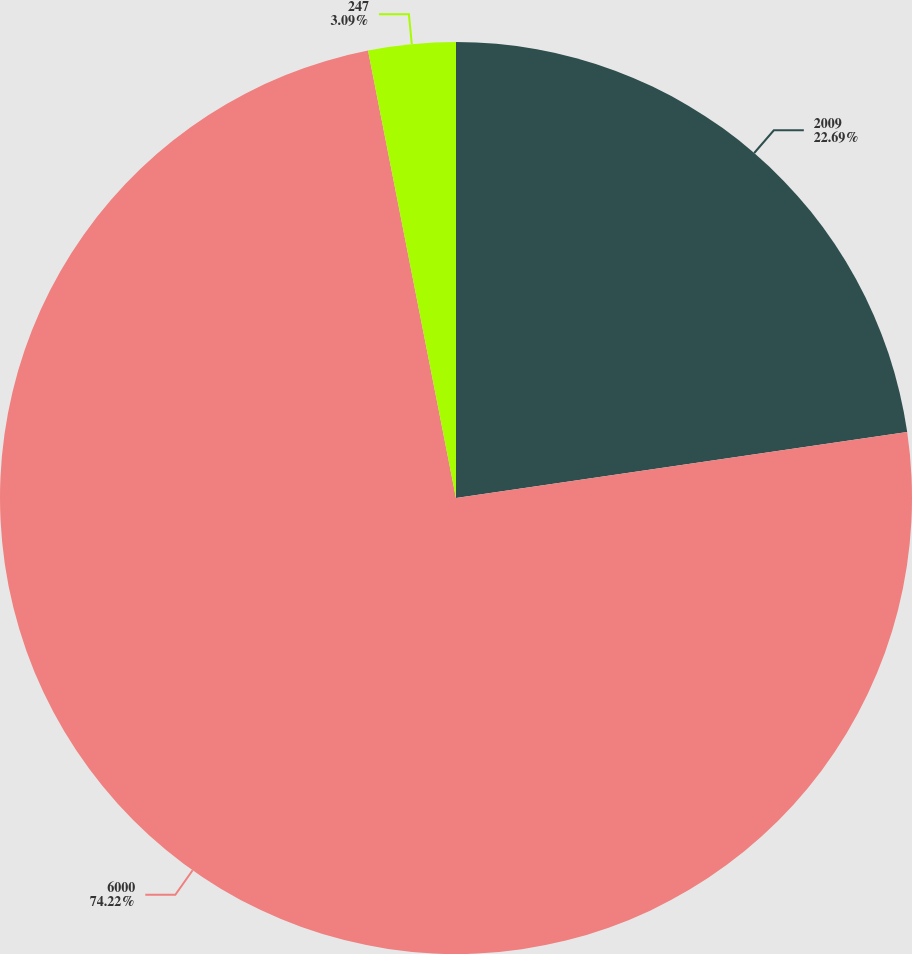Convert chart. <chart><loc_0><loc_0><loc_500><loc_500><pie_chart><fcel>2009<fcel>6000<fcel>247<nl><fcel>22.69%<fcel>74.22%<fcel>3.09%<nl></chart> 